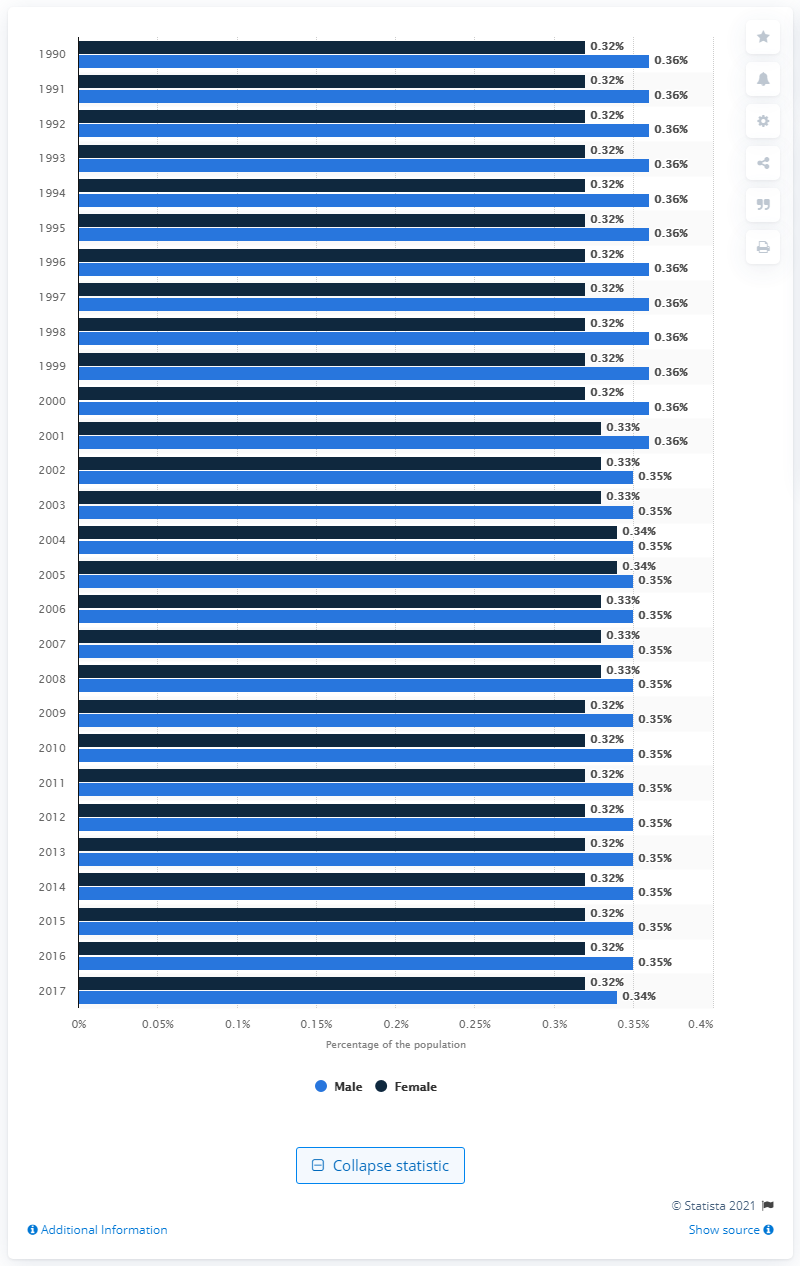Specify some key components in this picture. Schizophrenia was first diagnosed in the United States in 1990. 